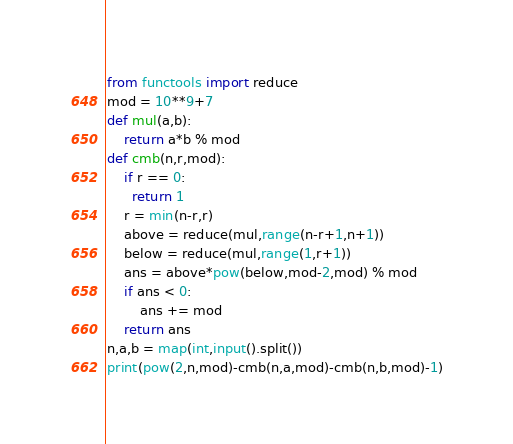<code> <loc_0><loc_0><loc_500><loc_500><_Python_>from functools import reduce
mod = 10**9+7
def mul(a,b):
    return a*b % mod
def cmb(n,r,mod):
    if r == 0:
      return 1
    r = min(n-r,r)
    above = reduce(mul,range(n-r+1,n+1)) 
    below = reduce(mul,range(1,r+1)) 
    ans = above*pow(below,mod-2,mod) % mod
    if ans < 0:
        ans += mod
    return ans
n,a,b = map(int,input().split())
print(pow(2,n,mod)-cmb(n,a,mod)-cmb(n,b,mod)-1)</code> 